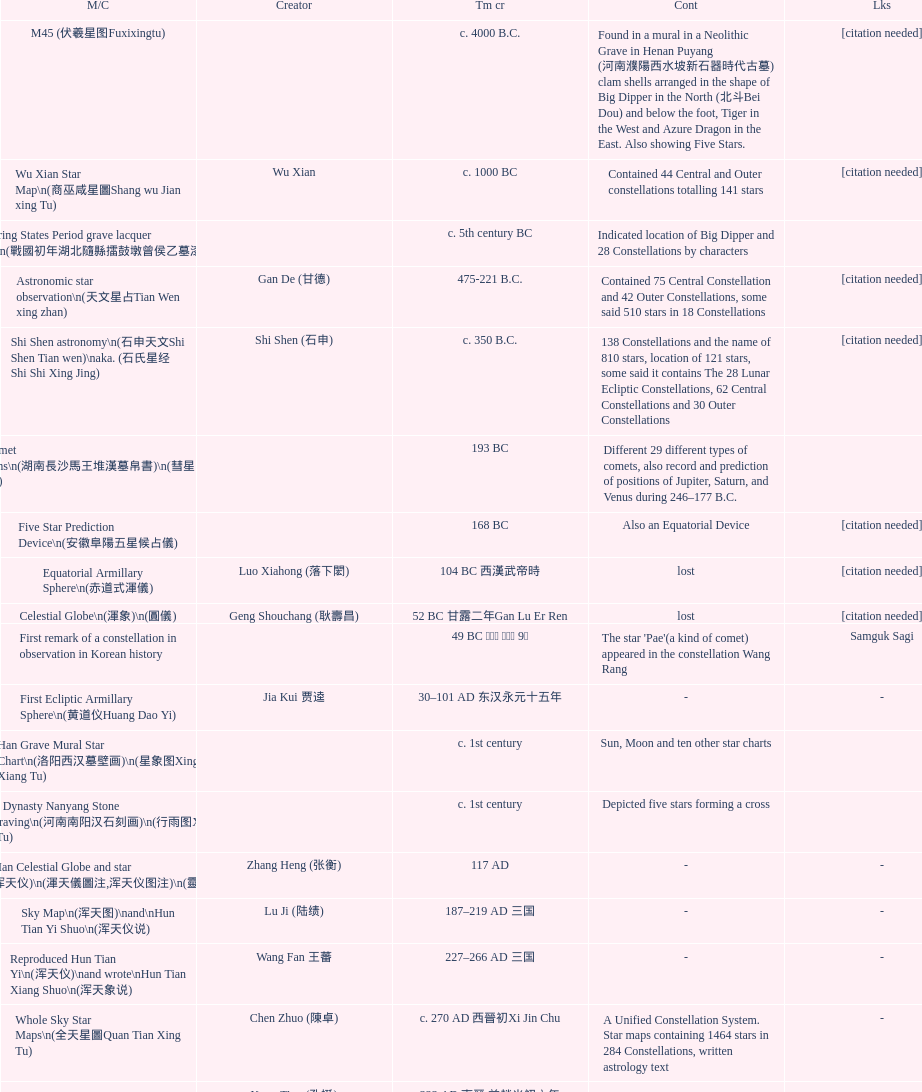Parse the table in full. {'header': ['M/C', 'Creator', 'Tm cr', 'Cont', 'Lks'], 'rows': [['M45 (伏羲星图Fuxixingtu)', '', 'c. 4000 B.C.', 'Found in a mural in a Neolithic Grave in Henan Puyang (河南濮陽西水坡新石器時代古墓) clam shells arranged in the shape of Big Dipper in the North (北斗Bei Dou) and below the foot, Tiger in the West and Azure Dragon in the East. Also showing Five Stars.', '[citation needed]'], ['Wu Xian Star Map\\n(商巫咸星圖Shang wu Jian xing Tu)', 'Wu Xian', 'c. 1000 BC', 'Contained 44 Central and Outer constellations totalling 141 stars', '[citation needed]'], ['Warring States Period grave lacquer box\\n(戰國初年湖北隨縣擂鼓墩曾侯乙墓漆箱)', '', 'c. 5th century BC', 'Indicated location of Big Dipper and 28 Constellations by characters', ''], ['Astronomic star observation\\n(天文星占Tian Wen xing zhan)', 'Gan De (甘德)', '475-221 B.C.', 'Contained 75 Central Constellation and 42 Outer Constellations, some said 510 stars in 18 Constellations', '[citation needed]'], ['Shi Shen astronomy\\n(石申天文Shi Shen Tian wen)\\naka. (石氏星经 Shi Shi Xing Jing)', 'Shi Shen (石申)', 'c. 350 B.C.', '138 Constellations and the name of 810 stars, location of 121 stars, some said it contains The 28 Lunar Ecliptic Constellations, 62 Central Constellations and 30 Outer Constellations', '[citation needed]'], ['Han Comet Diagrams\\n(湖南長沙馬王堆漢墓帛書)\\n(彗星圖Meng xing Tu)', '', '193 BC', 'Different 29 different types of comets, also record and prediction of positions of Jupiter, Saturn, and Venus during 246–177 B.C.', ''], ['Five Star Prediction Device\\n(安徽阜陽五星候占儀)', '', '168 BC', 'Also an Equatorial Device', '[citation needed]'], ['Equatorial Armillary Sphere\\n(赤道式渾儀)', 'Luo Xiahong (落下閎)', '104 BC 西漢武帝時', 'lost', '[citation needed]'], ['Celestial Globe\\n(渾象)\\n(圓儀)', 'Geng Shouchang (耿壽昌)', '52 BC 甘露二年Gan Lu Er Ren', 'lost', '[citation needed]'], ['First remark of a constellation in observation in Korean history', '', '49 BC 혁거세 거서간 9년', "The star 'Pae'(a kind of comet) appeared in the constellation Wang Rang", 'Samguk Sagi'], ['First Ecliptic Armillary Sphere\\n(黄道仪Huang Dao Yi)', 'Jia Kui 贾逵', '30–101 AD 东汉永元十五年', '-', '-'], ['Han Grave Mural Star Chart\\n(洛阳西汉墓壁画)\\n(星象图Xing Xiang Tu)', '', 'c. 1st century', 'Sun, Moon and ten other star charts', ''], ['Han Dynasty Nanyang Stone Engraving\\n(河南南阳汉石刻画)\\n(行雨图Xing Yu Tu)', '', 'c. 1st century', 'Depicted five stars forming a cross', ''], ['Eastern Han Celestial Globe and star maps\\n(浑天仪)\\n(渾天儀圖注,浑天仪图注)\\n(靈憲,灵宪)', 'Zhang Heng (张衡)', '117 AD', '-', '-'], ['Sky Map\\n(浑天图)\\nand\\nHun Tian Yi Shuo\\n(浑天仪说)', 'Lu Ji (陆绩)', '187–219 AD 三国', '-', '-'], ['Reproduced Hun Tian Yi\\n(浑天仪)\\nand wrote\\nHun Tian Xiang Shuo\\n(浑天象说)', 'Wang Fan 王蕃', '227–266 AD 三国', '-', '-'], ['Whole Sky Star Maps\\n(全天星圖Quan Tian Xing Tu)', 'Chen Zhuo (陳卓)', 'c. 270 AD 西晉初Xi Jin Chu', 'A Unified Constellation System. Star maps containing 1464 stars in 284 Constellations, written astrology text', '-'], ['Equatorial Armillary Sphere\\n(渾儀Hun Xi)', 'Kong Ting (孔挺)', '323 AD 東晉 前趙光初六年', 'level being used in this kind of device', '-'], ['Northern Wei Period Iron Armillary Sphere\\n(鐵渾儀)', 'Hu Lan (斛蘭)', 'Bei Wei\\plevel being used in this kind of device', '-', ''], ['Southern Dynasties Period Whole Sky Planetarium\\n(渾天象Hun Tian Xiang)', 'Qian Lezhi (錢樂之)', '443 AD 南朝劉宋元嘉年間', 'used red, black and white to differentiate stars from different star maps from Shi Shen, Gan De and Wu Xian 甘, 石, 巫三家星', '-'], ['Northern Wei Grave Dome Star Map\\n(河南洛陽北魏墓頂星圖)', '', '526 AD 北魏孝昌二年', 'about 300 stars, including the Big Dipper, some stars are linked by straight lines to form constellation. The Milky Way is also shown.', ''], ['Water-powered Planetarium\\n(水力渾天儀)', 'Geng Xun (耿詢)', 'c. 7th century 隋初Sui Chu', '-', '-'], ['Lingtai Miyuan\\n(靈台秘苑)', 'Yu Jicai (庾季才) and Zhou Fen (周墳)', '604 AD 隋Sui', 'incorporated star maps from different sources', '-'], ['Tang Dynasty Whole Sky Ecliptic Armillary Sphere\\n(渾天黃道儀)', 'Li Chunfeng 李淳風', '667 AD 貞觀七年', 'including Elliptic and Moon orbit, in addition to old equatorial design', '-'], ['The Dunhuang star map\\n(燉煌)', 'Dun Huang', '705–710 AD', '1,585 stars grouped into 257 clusters or "asterisms"', ''], ['Turfan Tomb Star Mural\\n(新疆吐鲁番阿斯塔那天文壁画)', '', '250–799 AD 唐', '28 Constellations, Milkyway and Five Stars', ''], ['Picture of Fuxi and Nüwa 新疆阿斯達那唐墓伏羲Fu Xi 女媧NV Wa像Xiang', '', 'Tang Dynasty', 'Picture of Fuxi and Nuwa together with some constellations', 'Image:Nuva fuxi.gif'], ['Tang Dynasty Armillary Sphere\\n(唐代渾儀Tang Dai Hun Xi)\\n(黃道遊儀Huang dao you xi)', 'Yixing Monk 一行和尚 (张遂)Zhang Sui and Liang Lingzan 梁令瓚', '683–727 AD', 'based on Han Dynasty Celestial Globe, recalibrated locations of 150 stars, determined that stars are moving', ''], ['Tang Dynasty Indian Horoscope Chart\\n(梵天火羅九曜)', 'Yixing Priest 一行和尚 (张遂)\\pZhang Sui\\p683–727 AD', 'simple diagrams of the 28 Constellation', '', ''], ['Kitora Kofun 法隆寺FaLong Si\u3000キトラ古墳 in Japan', '', 'c. late 7th century – early 8th century', 'Detailed whole sky map', ''], ['Treatise on Astrology of the Kaiyuan Era\\n(開元占経,开元占经Kai Yuan zhang Jing)', 'Gautama Siddha', '713 AD –', 'Collection of the three old star charts from Shi Shen, Gan De and Wu Xian. One of the most renowned collection recognized academically.', '-'], ['Big Dipper\\n(山東嘉祥武梁寺石刻北斗星)', '', '–', 'showing stars in Big Dipper', ''], ['Prajvalonisa Vjrabhairava Padvinasa-sri-dharani Scroll found in Japan 熾盛光佛頂大威德銷災吉祥陀羅尼經卷首扉畫', '', '972 AD 北宋開寶五年', 'Chinese 28 Constellations and Western Zodiac', '-'], ['Tangut Khara-Khoto (The Black City) Star Map 西夏黑水城星圖', '', '940 AD', 'A typical Qian Lezhi Style Star Map', '-'], ['Star Chart 五代吳越文穆王前元瓘墓石刻星象圖', '', '941–960 AD', '-', ''], ['Ancient Star Map 先天图 by 陈抟Chen Tuan', '', 'c. 11th Chen Tuan 宋Song', 'Perhaps based on studying of Puyong Ancient Star Map', 'Lost'], ['Song Dynasty Bronze Armillary Sphere 北宋至道銅渾儀', 'Han Xianfu 韓顯符', '1006 AD 宋道元年十二月', 'Similar to the Simplified Armillary by Kong Ting 孔挺, 晁崇 Chao Chong, 斛蘭 Hu Lan', '-'], ['Song Dynasty Bronze Armillary Sphere 北宋天文院黄道渾儀', 'Shu Yijian 舒易簡, Yu Yuan 于渊, Zhou Cong 周琮', '宋皇祐年中', 'Similar to the Armillary by Tang Dynasty Liang Lingzan 梁令瓚 and Yi Xing 一行', '-'], ['Song Dynasty Armillary Sphere 北宋簡化渾儀', 'Shen Kuo 沈括 and Huangfu Yu 皇甫愈', '1089 AD 熙寧七年', 'Simplied version of Tang Dynasty Device, removed the rarely used moon orbit.', '-'], ['Five Star Charts (新儀象法要)', 'Su Song 蘇頌', '1094 AD', '1464 stars grouped into 283 asterisms', 'Image:Su Song Star Map 1.JPG\\nImage:Su Song Star Map 2.JPG'], ['Song Dynasty Water-powered Planetarium 宋代 水运仪象台', 'Su Song 蘇頌 and Han Gonglian 韩公廉', 'c. 11th century', '-', ''], ['Liao Dynasty Tomb Dome Star Map 遼宣化张世卿墓頂星圖', '', '1116 AD 遼天庆六年', 'shown both the Chinese 28 Constellation encircled by Babylonian Zodiac', ''], ["Star Map in a woman's grave (江西德安 南宋周氏墓星相图)", '', '1127–1279 AD', 'Milky Way and 57 other stars.', ''], ['Hun Tian Yi Tong Xing Xiang Quan Tu, Suzhou Star Chart (蘇州石刻天文圖),淳祐天文図', 'Huang Shang (黃裳)', 'created in 1193, etched to stone in 1247 by Wang Zhi Yuan 王致遠', '1434 Stars grouped into 280 Asterisms in Northern Sky map', ''], ['Yuan Dynasty Simplified Armillary Sphere 元代簡儀', 'Guo Shou Jing 郭守敬', '1276–1279', 'Further simplied version of Song Dynasty Device', ''], ['Japanese Star Chart 格子月進図', '', '1324', 'Similar to Su Song Star Chart, original burned in air raids during World War II, only pictures left. Reprinted in 1984 by 佐佐木英治', ''], ['天象列次分野之図(Cheonsang Yeolcha Bunyajido)', '', '1395', 'Korean versions of Star Map in Stone. It was made in Chosun Dynasty and the constellation names were written in Chinese letter. The constellations as this was found in Japanese later. Contained 1,464 stars.', ''], ['Japanese Star Chart 瀧谷寺 天之図', '', 'c. 14th or 15th centuries 室町中期以前', '-', ''], ["Korean King Sejong's Armillary sphere", '', '1433', '-', ''], ['Star Chart', 'Mao Kun 茅坤', 'c. 1422', 'Polaris compared with Southern Cross and Alpha Centauri', 'zh:郑和航海图'], ['Korean Tomb', '', 'c. late 14th century', 'Big Dipper', ''], ['Ming Ancient Star Chart 北京隆福寺(古星圖)', '', 'c. 1453 明代', '1420 Stars, possibly based on old star maps from Tang Dynasty', ''], ['Chanshu Star Chart (明常熟石刻天文圖)', '', '1506', 'Based on Suzhou Star Chart, Northern Sky observed at 36.8 degrees North Latitude, 1466 stars grouped into 284 asterism', '-'], ['Ming Dynasty Star Map (渾蓋通憲圖說)', 'Matteo Ricci 利玛窦Li Ma Dou, recorded by Li Zhizao 李之藻', 'c. 1550', '-', ''], ['Tian Wun Tu (天问图)', 'Xiao Yun Cong 萧云从', 'c. 1600', 'Contained mapping of 12 constellations and 12 animals', ''], ['Zhou Tian Xuan Ji Tu (周天璇玑图) and He He Si Xiang Tu (和合四象圖) in Xing Ming Gui Zhi (性命圭旨)', 'by 尹真人高第弟子 published by 余永宁', '1615', 'Drawings of Armillary Sphere and four Chinese Celestial Animals with some notes. Related to Taoism.', ''], ['Korean Astronomy Book "Selected and Systematized Astronomy Notes" 天文類抄', '', '1623~1649', 'Contained some star maps', ''], ['Ming Dynasty General Star Map (赤道南北兩總星圖)', 'Xu Guang ci 徐光啟 and Adam Schall von Bell Tang Ruo Wang湯若望', '1634', '-', ''], ['Ming Dynasty diagrams of Armillary spheres and Celestial Globes', 'Xu Guang ci 徐光啟', 'c. 1699', '-', ''], ['Ming Dynasty Planetarium Machine (渾象 Hui Xiang)', '', 'c. 17th century', 'Ecliptic, Equator, and dividers of 28 constellation', ''], ['Copper Plate Star Map stored in Korea', '', '1652 順治九年shun zi jiu nian', '-', ''], ['Japanese Edo period Star Chart 天象列次之図 based on 天象列次分野之図 from Korean', 'Harumi Shibukawa 渋川春海Bu Chuan Chun Mei(保井春海Bao Jing Chun Mei)', '1670 寛文十年', '-', ''], ['The Celestial Globe 清康熙 天體儀', 'Ferdinand Verbiest 南懷仁', '1673', '1876 stars grouped into 282 asterisms', ''], ['Picture depicted Song Dynasty fictional astronomer (呉用 Wu Yong) with a Celestial Globe (天體儀)', 'Japanese painter', '1675', 'showing top portion of a Celestial Globe', 'File:Chinese astronomer 1675.jpg'], ['Japanese Edo period Star Chart 天文分野之図', 'Harumi Shibukawa 渋川春海BuJingChun Mei (保井春海Bao JingChunMei)', '1677 延宝五年', '-', ''], ['Korean star map in stone', '', '1687', '-', ''], ['Japanese Edo period Star Chart 天文図解', '井口常範', '1689 元禄2年', '-', '-'], ['Japanese Edo period Star Chart 古暦便覧備考', '苗村丈伯Mao Chun Zhang Bo', '1692 元禄5年', '-', '-'], ['Japanese star chart', 'Harumi Yasui written in Chinese', '1699 AD', 'A Japanese star chart of 1699 showing lunar stations', ''], ['Japanese Edo period Star Chart 天文成象Tian Wen Cheng xiang', '(渋川昔尹She Chuan Xi Yin) (保井昔尹Bao Jing Xi Yin)', '1699 元禄十二年', 'including Stars from Wu Shien (44 Constellation, 144 stars) in yellow; Gan De (118 Constellations, 511 stars) in black; Shi Shen (138 Constellations, 810 stars) in red and Harumi Shibukawa (61 Constellations, 308 stars) in blue;', ''], ['Japanese Star Chart 改正天文図説', '', 'unknown', 'Included stars from Harumi Shibukawa', ''], ['Korean Star Map Stone', '', 'c. 17th century', '-', ''], ['Korean Star Map', '', 'c. 17th century', '-', ''], ['Ceramic Ink Sink Cover', '', 'c. 17th century', 'Showing Big Dipper', ''], ['Korean Star Map Cube 方星圖', 'Italian Missionary Philippus Maria Grimardi 閔明我 (1639~1712)', 'c. early 18th century', '-', ''], ['Star Chart preserved in Japan based on a book from China 天経或問', 'You Zi liu 游子六', '1730 AD 江戸時代 享保15年', 'A Northern Sky Chart in Chinese', ''], ['Star Chart 清蒙文石刻(欽天監繪製天文圖) in Mongolia', '', '1727–1732 AD', '1550 stars grouped into 270 starisms.', ''], ['Korean Star Maps, North and South to the Eclliptic 黃道南北恒星圖', '', '1742', '-', ''], ['Japanese Edo period Star Chart 天経或問註解図巻\u3000下', '入江脩敬Ru Jiang YOu Jing', '1750 寛延3年', '-', '-'], ['Reproduction of an ancient device 璇璣玉衡', 'Dai Zhen 戴震', '1723–1777 AD', 'based on ancient record and his own interpretation', 'Could be similar to'], ['Rock Star Chart 清代天文石', '', 'c. 18th century', 'A Star Chart and general Astronomy Text', ''], ['Korean Complete Star Map (渾天全圖)', '', 'c. 18th century', '-', ''], ['Qing Dynasty Star Catalog (儀象考成,仪象考成)恒星表 and Star Map 黄道南北両星総図', 'Yun Lu 允禄 and Ignatius Kogler 戴进贤Dai Jin Xian 戴進賢, a German', 'Device made in 1744, book completed in 1757 清乾隆年间', '300 Constellations and 3083 Stars. Referenced Star Catalogue published by John Flamsteed', ''], ['Jingban Tianwen Quantu by Ma Junliang 马俊良', '', '1780–90 AD', 'mapping nations to the sky', ''], ['Japanese Edo period Illustration of a Star Measuring Device 平天儀図解', 'Yan Qiao Shan Bing Heng 岩橋善兵衛', '1802 Xiang He Er Nian 享和二年', '-', 'The device could be similar to'], ['North Sky Map 清嘉庆年间Huang Dao Zhong Xi He Tu(黄道中西合图)', 'Xu Choujun 徐朝俊', '1807 AD', 'More than 1000 stars and the 28 consellation', ''], ['Japanese Edo period Star Chart 天象総星之図', 'Chao Ye Bei Shui 朝野北水', '1814 文化十一年', '-', '-'], ['Japanese Edo period Star Chart 新制天球星象記', '田中政均', '1815 文化十二年', '-', '-'], ['Japanese Edo period Star Chart 天球図', '坂部廣胖', '1816 文化十三年', '-', '-'], ['Chinese Star map', 'John Reeves esq', '1819 AD', 'Printed map showing Chinese names of stars and constellations', ''], ['Japanese Edo period Star Chart 昊天図説詳解', '佐藤祐之', '1824 文政七年', '-', '-'], ['Japanese Edo period Star Chart 星図歩天歌', '小島好謙 and 鈴木世孝', '1824 文政七年', '-', '-'], ['Japanese Edo period Star Chart', '鈴木世孝', '1824 文政七年', '-', '-'], ['Japanese Edo period Star Chart 天象管鈔 天体図 (天文星象図解)', '長久保赤水', '1824 文政七年', '-', ''], ['Japanese Edo period Star Measuring Device 中星儀', '足立信順Zhu Li Xin Shun', '1824 文政七年', '-', '-'], ['Japanese Star Map 天象一覧図 in Kanji', '桜田虎門', '1824 AD 文政７年', 'Printed map showing Chinese names of stars and constellations', ''], ['Korean Star Map 天象列次分野之図 in Kanji', '', 'c. 19th century', 'Printed map showing Chinese names of stars and constellations', '[18]'], ['Korean Star Map', '', 'c. 19th century, late Choson Period', '-', ''], ['Korean Star maps: Star Map South to the Ecliptic 黃道南恒星圖 and Star Map South to the Ecliptic 黃道北恒星圖', '', 'c. 19th century', 'Perhaps influenced by Adam Schall von Bell Tang Ruo wang 湯若望 (1591–1666) and P. Ignatius Koegler 戴進賢 (1680–1748)', ''], ['Korean Complete map of the celestial sphere (渾天全圖)', '', 'c. 19th century', '-', ''], ['Korean Book of Stars 經星', '', 'c. 19th century', 'Several star maps', ''], ['Japanese Edo period Star Chart 方円星図,方圓星図 and 増補分度星図方図', '石坂常堅', '1826b文政9年', '-', '-'], ['Japanese Star Chart', '伊能忠誨', 'c. 19th century', '-', '-'], ['Japanese Edo period Star Chart 天球図説', '古筆源了材', '1835 天保6年', '-', '-'], ['Qing Dynasty Star Catalog (儀象考成續編)星表', '', '1844', 'Appendix to Yi Xian Kao Cheng, listed 3240 stars (added 163, removed 6)', ''], ['Stars map (恒星赤道経緯度図)stored in Japan', '', '1844 道光24年 or 1848', '-', '-'], ['Japanese Edo period Star Chart 経緯簡儀用法', '藤岡有貞', '1845 弘化２年', '-', '-'], ['Japanese Edo period Star Chart 分野星図', '高塚福昌, 阿部比輔, 上条景弘', '1849 嘉永2年', '-', '-'], ['Japanese Late Edo period Star Chart 天文図屏風', '遠藤盛俊', 'late Edo Period 江戸時代後期', '-', '-'], ['Japanese Star Chart 天体図', '三浦梅園', '-', '-', '-'], ['Japanese Star Chart 梅園星図', '高橋景保', '-', '-', ''], ['Korean Book of New Song of the Sky Pacer 新法步天歌', '李俊養', '1862', 'Star maps and a revised version of the Song of Sky Pacer', ''], ['Stars South of Equator, Stars North of Equator (赤道南恆星圖,赤道北恆星圖)', '', '1875～1908 清末光緒年間', 'Similar to Ming Dynasty General Star Map', ''], ['Fuxi 64 gua 28 xu wood carving 天水市卦台山伏羲六十四卦二十八宿全图', '', 'modern', '-', '-'], ['Korean Map of Heaven and Earth 天地圖', '', 'c. 19th century', '28 Constellations and geographic map', ''], ['Korean version of 28 Constellation 列宿圖', '', 'c. 19th century', '28 Constellations, some named differently from their Chinese counterparts', ''], ['Korean Star Chart 渾天図', '朴?', '-', '-', '-'], ['Star Chart in a Dao Temple 玉皇山道觀星圖', '', '1940 AD', '-', '-'], ['Simplified Chinese and Western Star Map', 'Yi Shi Tong 伊世同', 'Aug. 1963', 'Star Map showing Chinese Xingquan and Western Constellation boundaries', ''], ['Sky Map', 'Yu Xi Dao Ren 玉溪道人', '1987', 'Star Map with captions', ''], ['The Chinese Sky during the Han Constellating Stars and Society', 'Sun Xiaochun and Jacob Kistemaker', '1997 AD', 'An attempt to recreate night sky seen by Chinese 2000 years ago', ''], ['Star map', '', 'Recent', 'An attempt by a Japanese to reconstruct the night sky for a historical event around 235 AD 秋風五丈原', ''], ['Star maps', '', 'Recent', 'Chinese 28 Constellation with Chinese and Japanese captions', ''], ['SinoSky Beta 2.0', '', '2002', 'A computer program capable of showing Chinese Xingguans alongside with western constellations, lists about 700 stars with Chinese names.', ''], ['AEEA Star maps', '', 'Modern', 'Good reconstruction and explanation of Chinese constellations', ''], ['Wikipedia Star maps', '', 'Modern', '-', 'zh:華蓋星'], ['28 Constellations, big dipper and 4 symbols Star map', '', 'Modern', '-', ''], ['Collection of printed star maps', '', 'Modern', '-', ''], ['28 Xu Star map and catalog', '-', 'Modern', 'Stars around ecliptic', ''], ['HNSKY Korean/Chinese Supplement', 'Jeong, Tae-Min(jtm71)/Chuang_Siau_Chin', 'Modern', 'Korean supplement is based on CheonSangYeulChaBunYaZiDo (B.C.100 ~ A.D.100)', ''], ['Stellarium Chinese and Korean Sky Culture', 'G.S.K. Lee; Jeong, Tae-Min(jtm71); Yu-Pu Wang (evanzxcv)', 'Modern', 'Major Xingguans and Star names', ''], ['修真內外火侯全圖 Huo Hou Tu', 'Xi Chun Sheng Chong Hui\\p2005 redrawn, original unknown', 'illustrations of Milkyway and star maps, Chinese constellations in Taoism view', '', ''], ['Star Map with illustrations for Xingguans', '坐井★观星Zuo Jing Guan Xing', 'Modern', 'illustrations for cylindrical and circular polar maps', ''], ['Sky in Google Earth KML', '', 'Modern', 'Attempts to show Chinese Star Maps on Google Earth', '']]} What is the name of the oldest map/catalog? M45. 